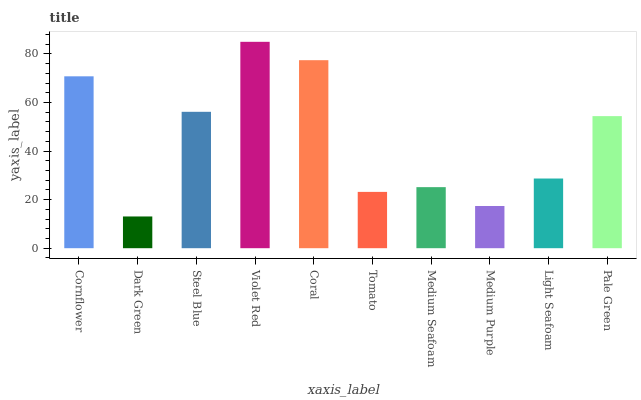Is Dark Green the minimum?
Answer yes or no. Yes. Is Violet Red the maximum?
Answer yes or no. Yes. Is Steel Blue the minimum?
Answer yes or no. No. Is Steel Blue the maximum?
Answer yes or no. No. Is Steel Blue greater than Dark Green?
Answer yes or no. Yes. Is Dark Green less than Steel Blue?
Answer yes or no. Yes. Is Dark Green greater than Steel Blue?
Answer yes or no. No. Is Steel Blue less than Dark Green?
Answer yes or no. No. Is Pale Green the high median?
Answer yes or no. Yes. Is Light Seafoam the low median?
Answer yes or no. Yes. Is Cornflower the high median?
Answer yes or no. No. Is Medium Purple the low median?
Answer yes or no. No. 